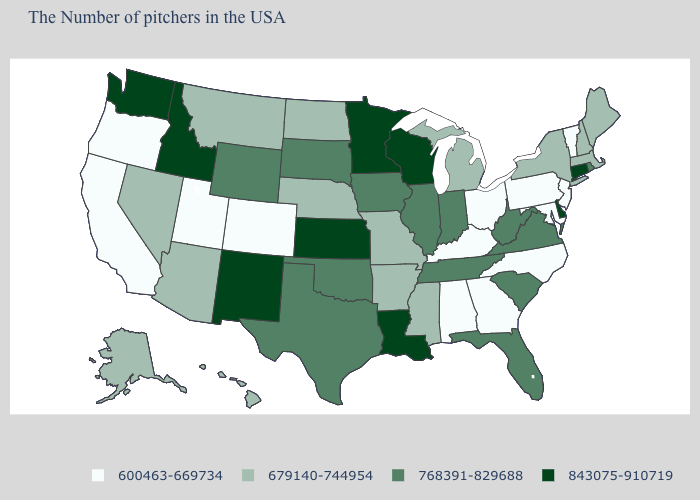How many symbols are there in the legend?
Give a very brief answer. 4. Name the states that have a value in the range 679140-744954?
Concise answer only. Maine, Massachusetts, New Hampshire, New York, Michigan, Mississippi, Missouri, Arkansas, Nebraska, North Dakota, Montana, Arizona, Nevada, Alaska, Hawaii. Which states have the lowest value in the USA?
Keep it brief. Vermont, New Jersey, Maryland, Pennsylvania, North Carolina, Ohio, Georgia, Kentucky, Alabama, Colorado, Utah, California, Oregon. What is the value of Maryland?
Write a very short answer. 600463-669734. Among the states that border New York , does Vermont have the lowest value?
Answer briefly. Yes. What is the lowest value in states that border Kansas?
Concise answer only. 600463-669734. Which states have the lowest value in the South?
Short answer required. Maryland, North Carolina, Georgia, Kentucky, Alabama. What is the lowest value in states that border Georgia?
Be succinct. 600463-669734. What is the value of Missouri?
Short answer required. 679140-744954. Name the states that have a value in the range 679140-744954?
Answer briefly. Maine, Massachusetts, New Hampshire, New York, Michigan, Mississippi, Missouri, Arkansas, Nebraska, North Dakota, Montana, Arizona, Nevada, Alaska, Hawaii. Does the map have missing data?
Quick response, please. No. What is the value of Missouri?
Write a very short answer. 679140-744954. Does Pennsylvania have the lowest value in the Northeast?
Concise answer only. Yes. What is the highest value in the MidWest ?
Answer briefly. 843075-910719. Is the legend a continuous bar?
Answer briefly. No. 